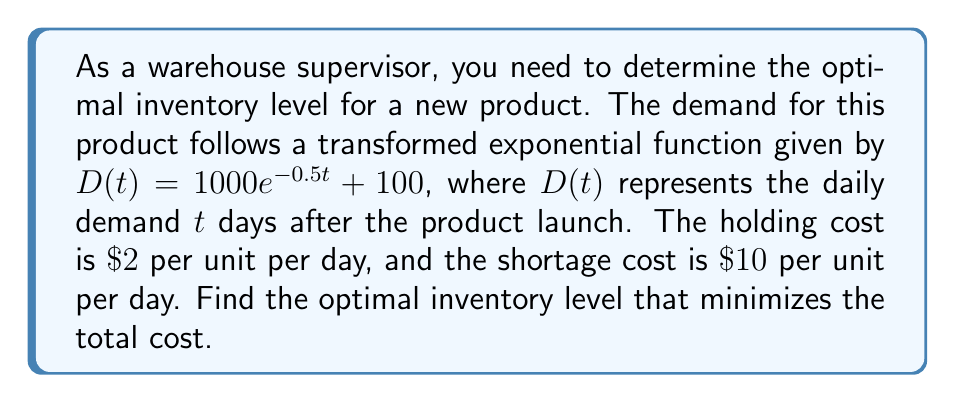Provide a solution to this math problem. To find the optimal inventory level, we need to follow these steps:

1) The optimal inventory level occurs when the probability of stockout equals the critical ratio (CR):

   $CR = \frac{\text{Shortage Cost}}{\text{Shortage Cost + Holding Cost}} = \frac{10}{10 + 2} = \frac{5}{6}$

2) For the exponential distribution, the probability of demand being less than or equal to $x$ is given by:

   $P(D \leq x) = 1 - e^{-\lambda x}$

3) In our transformed function $D(t) = 1000e^{-0.5t} + 100$, we need to isolate the exponential part:

   $1000e^{-0.5t} = D(t) - 100$

4) Dividing both sides by 1000:

   $e^{-0.5t} = \frac{D(t) - 100}{1000}$

5) Taking the natural log of both sides:

   $-0.5t = \ln(\frac{D(t) - 100}{1000})$

6) Solving for $t$:

   $t = -2\ln(\frac{D(t) - 100}{1000})$

7) Now, we can set up the equation using the critical ratio:

   $1 - e^{-\lambda x} = \frac{5}{6}$

8) Solving for $x$:

   $e^{-\lambda x} = \frac{1}{6}$
   $-\lambda x = \ln(\frac{1}{6})$
   $x = -\frac{1}{\lambda}\ln(\frac{1}{6})$

9) Substituting $\lambda = \frac{1}{2}$ from step 6:

   $x = -2\ln(\frac{1}{6}) \approx 3.58$

10) This $x$ represents the number of days. To find the actual demand, we plug this back into our original function:

    $D(3.58) = 1000e^{-0.5(3.58)} + 100 \approx 415.8$

Therefore, the optimal inventory level is approximately 416 units.
Answer: 416 units 